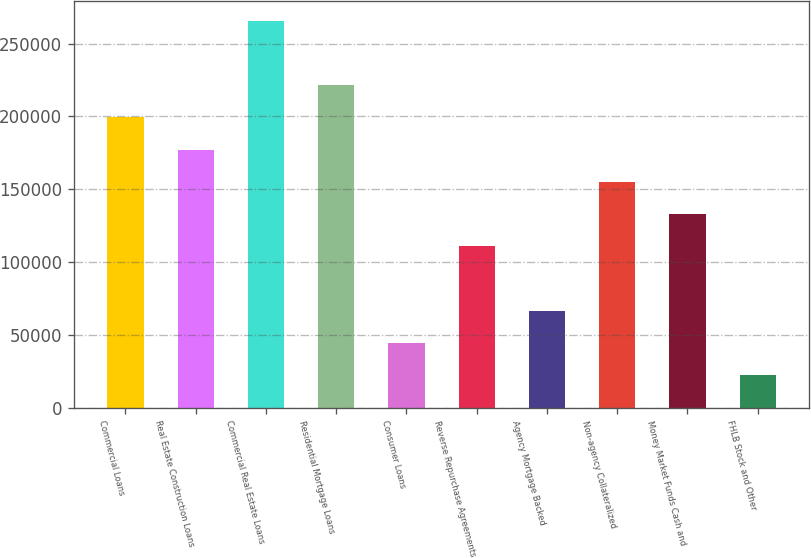Convert chart. <chart><loc_0><loc_0><loc_500><loc_500><bar_chart><fcel>Commercial Loans<fcel>Real Estate Construction Loans<fcel>Commercial Real Estate Loans<fcel>Residential Mortgage Loans<fcel>Consumer Loans<fcel>Reverse Repurchase Agreements<fcel>Agency Mortgage Backed<fcel>Non-agency Collateralized<fcel>Money Market Funds Cash and<fcel>FHLB Stock and Other<nl><fcel>199295<fcel>177165<fcel>265687<fcel>221426<fcel>44380.4<fcel>110772<fcel>66511.1<fcel>155034<fcel>132903<fcel>22249.7<nl></chart> 